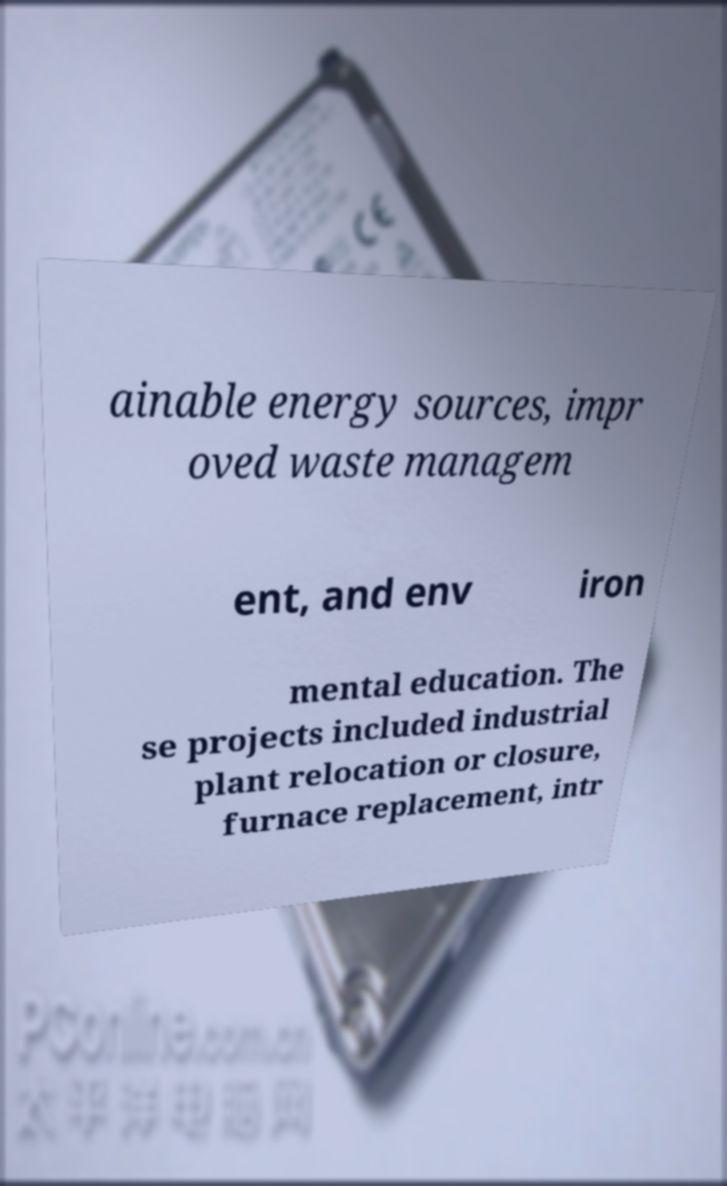Could you extract and type out the text from this image? ainable energy sources, impr oved waste managem ent, and env iron mental education. The se projects included industrial plant relocation or closure, furnace replacement, intr 